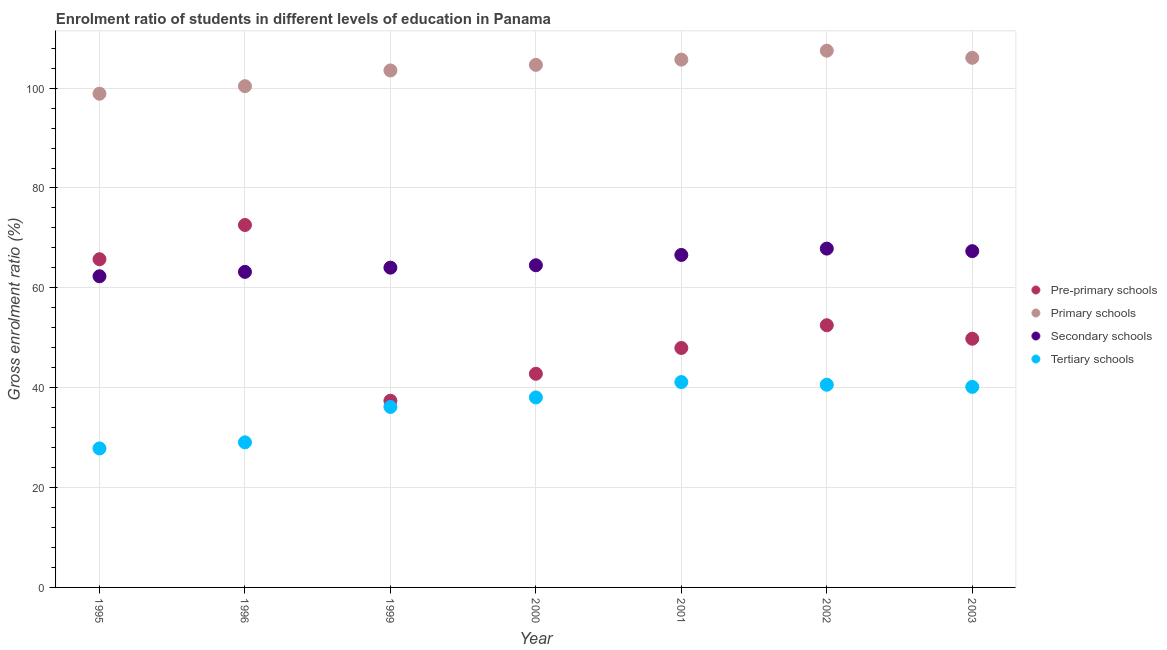How many different coloured dotlines are there?
Your response must be concise. 4. What is the gross enrolment ratio in primary schools in 1996?
Provide a short and direct response. 100.39. Across all years, what is the maximum gross enrolment ratio in tertiary schools?
Keep it short and to the point. 41.13. Across all years, what is the minimum gross enrolment ratio in tertiary schools?
Offer a very short reply. 27.84. In which year was the gross enrolment ratio in primary schools maximum?
Your answer should be compact. 2002. What is the total gross enrolment ratio in secondary schools in the graph?
Your response must be concise. 455.89. What is the difference between the gross enrolment ratio in primary schools in 1996 and that in 2002?
Offer a very short reply. -7.1. What is the difference between the gross enrolment ratio in secondary schools in 2001 and the gross enrolment ratio in tertiary schools in 1999?
Make the answer very short. 30.44. What is the average gross enrolment ratio in tertiary schools per year?
Your answer should be compact. 36.14. In the year 1996, what is the difference between the gross enrolment ratio in tertiary schools and gross enrolment ratio in secondary schools?
Offer a very short reply. -34.14. In how many years, is the gross enrolment ratio in secondary schools greater than 72 %?
Offer a terse response. 0. What is the ratio of the gross enrolment ratio in tertiary schools in 2002 to that in 2003?
Keep it short and to the point. 1.01. Is the difference between the gross enrolment ratio in tertiary schools in 2001 and 2002 greater than the difference between the gross enrolment ratio in pre-primary schools in 2001 and 2002?
Give a very brief answer. Yes. What is the difference between the highest and the second highest gross enrolment ratio in tertiary schools?
Ensure brevity in your answer.  0.53. What is the difference between the highest and the lowest gross enrolment ratio in tertiary schools?
Offer a very short reply. 13.29. Is the sum of the gross enrolment ratio in pre-primary schools in 2001 and 2002 greater than the maximum gross enrolment ratio in tertiary schools across all years?
Make the answer very short. Yes. Does the gross enrolment ratio in tertiary schools monotonically increase over the years?
Offer a terse response. No. Is the gross enrolment ratio in secondary schools strictly greater than the gross enrolment ratio in pre-primary schools over the years?
Provide a succinct answer. No. Is the gross enrolment ratio in secondary schools strictly less than the gross enrolment ratio in pre-primary schools over the years?
Make the answer very short. No. How many dotlines are there?
Offer a terse response. 4. How many years are there in the graph?
Ensure brevity in your answer.  7. What is the difference between two consecutive major ticks on the Y-axis?
Give a very brief answer. 20. Are the values on the major ticks of Y-axis written in scientific E-notation?
Ensure brevity in your answer.  No. Does the graph contain any zero values?
Provide a succinct answer. No. What is the title of the graph?
Your answer should be compact. Enrolment ratio of students in different levels of education in Panama. Does "Plant species" appear as one of the legend labels in the graph?
Your answer should be compact. No. What is the label or title of the X-axis?
Ensure brevity in your answer.  Year. What is the label or title of the Y-axis?
Your answer should be compact. Gross enrolment ratio (%). What is the Gross enrolment ratio (%) of Pre-primary schools in 1995?
Provide a succinct answer. 65.73. What is the Gross enrolment ratio (%) of Primary schools in 1995?
Offer a very short reply. 98.88. What is the Gross enrolment ratio (%) in Secondary schools in 1995?
Keep it short and to the point. 62.32. What is the Gross enrolment ratio (%) in Tertiary schools in 1995?
Provide a short and direct response. 27.84. What is the Gross enrolment ratio (%) in Pre-primary schools in 1996?
Offer a terse response. 72.59. What is the Gross enrolment ratio (%) of Primary schools in 1996?
Your response must be concise. 100.39. What is the Gross enrolment ratio (%) in Secondary schools in 1996?
Your response must be concise. 63.2. What is the Gross enrolment ratio (%) in Tertiary schools in 1996?
Provide a succinct answer. 29.06. What is the Gross enrolment ratio (%) of Pre-primary schools in 1999?
Offer a very short reply. 37.39. What is the Gross enrolment ratio (%) in Primary schools in 1999?
Provide a succinct answer. 103.54. What is the Gross enrolment ratio (%) of Secondary schools in 1999?
Your answer should be compact. 64.04. What is the Gross enrolment ratio (%) in Tertiary schools in 1999?
Offer a very short reply. 36.15. What is the Gross enrolment ratio (%) in Pre-primary schools in 2000?
Offer a very short reply. 42.79. What is the Gross enrolment ratio (%) of Primary schools in 2000?
Your answer should be very brief. 104.66. What is the Gross enrolment ratio (%) in Secondary schools in 2000?
Your response must be concise. 64.52. What is the Gross enrolment ratio (%) in Tertiary schools in 2000?
Your response must be concise. 38.05. What is the Gross enrolment ratio (%) in Pre-primary schools in 2001?
Your answer should be very brief. 47.96. What is the Gross enrolment ratio (%) in Primary schools in 2001?
Your answer should be very brief. 105.71. What is the Gross enrolment ratio (%) of Secondary schools in 2001?
Offer a terse response. 66.59. What is the Gross enrolment ratio (%) in Tertiary schools in 2001?
Your response must be concise. 41.13. What is the Gross enrolment ratio (%) of Pre-primary schools in 2002?
Give a very brief answer. 52.51. What is the Gross enrolment ratio (%) of Primary schools in 2002?
Make the answer very short. 107.49. What is the Gross enrolment ratio (%) in Secondary schools in 2002?
Offer a terse response. 67.86. What is the Gross enrolment ratio (%) of Tertiary schools in 2002?
Your answer should be compact. 40.6. What is the Gross enrolment ratio (%) in Pre-primary schools in 2003?
Give a very brief answer. 49.81. What is the Gross enrolment ratio (%) in Primary schools in 2003?
Your response must be concise. 106.07. What is the Gross enrolment ratio (%) of Secondary schools in 2003?
Your answer should be compact. 67.35. What is the Gross enrolment ratio (%) in Tertiary schools in 2003?
Give a very brief answer. 40.17. Across all years, what is the maximum Gross enrolment ratio (%) of Pre-primary schools?
Your answer should be very brief. 72.59. Across all years, what is the maximum Gross enrolment ratio (%) of Primary schools?
Ensure brevity in your answer.  107.49. Across all years, what is the maximum Gross enrolment ratio (%) in Secondary schools?
Make the answer very short. 67.86. Across all years, what is the maximum Gross enrolment ratio (%) in Tertiary schools?
Your response must be concise. 41.13. Across all years, what is the minimum Gross enrolment ratio (%) of Pre-primary schools?
Offer a terse response. 37.39. Across all years, what is the minimum Gross enrolment ratio (%) of Primary schools?
Give a very brief answer. 98.88. Across all years, what is the minimum Gross enrolment ratio (%) in Secondary schools?
Keep it short and to the point. 62.32. Across all years, what is the minimum Gross enrolment ratio (%) of Tertiary schools?
Provide a succinct answer. 27.84. What is the total Gross enrolment ratio (%) in Pre-primary schools in the graph?
Make the answer very short. 368.78. What is the total Gross enrolment ratio (%) in Primary schools in the graph?
Offer a terse response. 726.75. What is the total Gross enrolment ratio (%) of Secondary schools in the graph?
Offer a terse response. 455.89. What is the total Gross enrolment ratio (%) of Tertiary schools in the graph?
Ensure brevity in your answer.  252.99. What is the difference between the Gross enrolment ratio (%) of Pre-primary schools in 1995 and that in 1996?
Give a very brief answer. -6.86. What is the difference between the Gross enrolment ratio (%) of Primary schools in 1995 and that in 1996?
Your answer should be compact. -1.51. What is the difference between the Gross enrolment ratio (%) of Secondary schools in 1995 and that in 1996?
Provide a short and direct response. -0.88. What is the difference between the Gross enrolment ratio (%) of Tertiary schools in 1995 and that in 1996?
Make the answer very short. -1.22. What is the difference between the Gross enrolment ratio (%) in Pre-primary schools in 1995 and that in 1999?
Offer a terse response. 28.34. What is the difference between the Gross enrolment ratio (%) of Primary schools in 1995 and that in 1999?
Your answer should be compact. -4.66. What is the difference between the Gross enrolment ratio (%) of Secondary schools in 1995 and that in 1999?
Provide a succinct answer. -1.72. What is the difference between the Gross enrolment ratio (%) in Tertiary schools in 1995 and that in 1999?
Your answer should be compact. -8.32. What is the difference between the Gross enrolment ratio (%) in Pre-primary schools in 1995 and that in 2000?
Provide a short and direct response. 22.94. What is the difference between the Gross enrolment ratio (%) of Primary schools in 1995 and that in 2000?
Provide a short and direct response. -5.78. What is the difference between the Gross enrolment ratio (%) in Secondary schools in 1995 and that in 2000?
Keep it short and to the point. -2.2. What is the difference between the Gross enrolment ratio (%) of Tertiary schools in 1995 and that in 2000?
Provide a succinct answer. -10.21. What is the difference between the Gross enrolment ratio (%) of Pre-primary schools in 1995 and that in 2001?
Provide a succinct answer. 17.77. What is the difference between the Gross enrolment ratio (%) in Primary schools in 1995 and that in 2001?
Your answer should be compact. -6.83. What is the difference between the Gross enrolment ratio (%) of Secondary schools in 1995 and that in 2001?
Give a very brief answer. -4.27. What is the difference between the Gross enrolment ratio (%) in Tertiary schools in 1995 and that in 2001?
Offer a very short reply. -13.29. What is the difference between the Gross enrolment ratio (%) of Pre-primary schools in 1995 and that in 2002?
Offer a terse response. 13.22. What is the difference between the Gross enrolment ratio (%) of Primary schools in 1995 and that in 2002?
Give a very brief answer. -8.61. What is the difference between the Gross enrolment ratio (%) of Secondary schools in 1995 and that in 2002?
Provide a succinct answer. -5.54. What is the difference between the Gross enrolment ratio (%) of Tertiary schools in 1995 and that in 2002?
Make the answer very short. -12.76. What is the difference between the Gross enrolment ratio (%) of Pre-primary schools in 1995 and that in 2003?
Keep it short and to the point. 15.92. What is the difference between the Gross enrolment ratio (%) in Primary schools in 1995 and that in 2003?
Your answer should be very brief. -7.19. What is the difference between the Gross enrolment ratio (%) of Secondary schools in 1995 and that in 2003?
Offer a very short reply. -5.03. What is the difference between the Gross enrolment ratio (%) in Tertiary schools in 1995 and that in 2003?
Offer a terse response. -12.33. What is the difference between the Gross enrolment ratio (%) in Pre-primary schools in 1996 and that in 1999?
Make the answer very short. 35.2. What is the difference between the Gross enrolment ratio (%) of Primary schools in 1996 and that in 1999?
Offer a very short reply. -3.15. What is the difference between the Gross enrolment ratio (%) of Secondary schools in 1996 and that in 1999?
Ensure brevity in your answer.  -0.85. What is the difference between the Gross enrolment ratio (%) in Tertiary schools in 1996 and that in 1999?
Your response must be concise. -7.09. What is the difference between the Gross enrolment ratio (%) in Pre-primary schools in 1996 and that in 2000?
Provide a short and direct response. 29.8. What is the difference between the Gross enrolment ratio (%) of Primary schools in 1996 and that in 2000?
Give a very brief answer. -4.27. What is the difference between the Gross enrolment ratio (%) of Secondary schools in 1996 and that in 2000?
Your answer should be very brief. -1.33. What is the difference between the Gross enrolment ratio (%) of Tertiary schools in 1996 and that in 2000?
Provide a succinct answer. -8.99. What is the difference between the Gross enrolment ratio (%) of Pre-primary schools in 1996 and that in 2001?
Ensure brevity in your answer.  24.63. What is the difference between the Gross enrolment ratio (%) of Primary schools in 1996 and that in 2001?
Offer a very short reply. -5.32. What is the difference between the Gross enrolment ratio (%) of Secondary schools in 1996 and that in 2001?
Keep it short and to the point. -3.39. What is the difference between the Gross enrolment ratio (%) of Tertiary schools in 1996 and that in 2001?
Provide a short and direct response. -12.07. What is the difference between the Gross enrolment ratio (%) of Pre-primary schools in 1996 and that in 2002?
Provide a succinct answer. 20.08. What is the difference between the Gross enrolment ratio (%) in Primary schools in 1996 and that in 2002?
Your answer should be very brief. -7.1. What is the difference between the Gross enrolment ratio (%) of Secondary schools in 1996 and that in 2002?
Your response must be concise. -4.66. What is the difference between the Gross enrolment ratio (%) in Tertiary schools in 1996 and that in 2002?
Provide a succinct answer. -11.54. What is the difference between the Gross enrolment ratio (%) of Pre-primary schools in 1996 and that in 2003?
Your response must be concise. 22.78. What is the difference between the Gross enrolment ratio (%) in Primary schools in 1996 and that in 2003?
Provide a short and direct response. -5.68. What is the difference between the Gross enrolment ratio (%) of Secondary schools in 1996 and that in 2003?
Your answer should be compact. -4.15. What is the difference between the Gross enrolment ratio (%) in Tertiary schools in 1996 and that in 2003?
Make the answer very short. -11.11. What is the difference between the Gross enrolment ratio (%) of Pre-primary schools in 1999 and that in 2000?
Offer a very short reply. -5.4. What is the difference between the Gross enrolment ratio (%) of Primary schools in 1999 and that in 2000?
Provide a short and direct response. -1.12. What is the difference between the Gross enrolment ratio (%) of Secondary schools in 1999 and that in 2000?
Provide a short and direct response. -0.48. What is the difference between the Gross enrolment ratio (%) in Tertiary schools in 1999 and that in 2000?
Your answer should be compact. -1.9. What is the difference between the Gross enrolment ratio (%) in Pre-primary schools in 1999 and that in 2001?
Your answer should be very brief. -10.57. What is the difference between the Gross enrolment ratio (%) in Primary schools in 1999 and that in 2001?
Provide a short and direct response. -2.17. What is the difference between the Gross enrolment ratio (%) in Secondary schools in 1999 and that in 2001?
Provide a short and direct response. -2.55. What is the difference between the Gross enrolment ratio (%) of Tertiary schools in 1999 and that in 2001?
Offer a terse response. -4.98. What is the difference between the Gross enrolment ratio (%) of Pre-primary schools in 1999 and that in 2002?
Provide a short and direct response. -15.12. What is the difference between the Gross enrolment ratio (%) of Primary schools in 1999 and that in 2002?
Make the answer very short. -3.95. What is the difference between the Gross enrolment ratio (%) in Secondary schools in 1999 and that in 2002?
Provide a succinct answer. -3.82. What is the difference between the Gross enrolment ratio (%) in Tertiary schools in 1999 and that in 2002?
Give a very brief answer. -4.44. What is the difference between the Gross enrolment ratio (%) in Pre-primary schools in 1999 and that in 2003?
Ensure brevity in your answer.  -12.42. What is the difference between the Gross enrolment ratio (%) of Primary schools in 1999 and that in 2003?
Your answer should be very brief. -2.53. What is the difference between the Gross enrolment ratio (%) of Secondary schools in 1999 and that in 2003?
Provide a short and direct response. -3.31. What is the difference between the Gross enrolment ratio (%) of Tertiary schools in 1999 and that in 2003?
Keep it short and to the point. -4.01. What is the difference between the Gross enrolment ratio (%) of Pre-primary schools in 2000 and that in 2001?
Keep it short and to the point. -5.17. What is the difference between the Gross enrolment ratio (%) in Primary schools in 2000 and that in 2001?
Your answer should be very brief. -1.05. What is the difference between the Gross enrolment ratio (%) of Secondary schools in 2000 and that in 2001?
Give a very brief answer. -2.07. What is the difference between the Gross enrolment ratio (%) in Tertiary schools in 2000 and that in 2001?
Give a very brief answer. -3.08. What is the difference between the Gross enrolment ratio (%) of Pre-primary schools in 2000 and that in 2002?
Provide a succinct answer. -9.72. What is the difference between the Gross enrolment ratio (%) of Primary schools in 2000 and that in 2002?
Your answer should be very brief. -2.83. What is the difference between the Gross enrolment ratio (%) in Secondary schools in 2000 and that in 2002?
Provide a short and direct response. -3.34. What is the difference between the Gross enrolment ratio (%) of Tertiary schools in 2000 and that in 2002?
Offer a terse response. -2.55. What is the difference between the Gross enrolment ratio (%) of Pre-primary schools in 2000 and that in 2003?
Your answer should be very brief. -7.02. What is the difference between the Gross enrolment ratio (%) in Primary schools in 2000 and that in 2003?
Make the answer very short. -1.41. What is the difference between the Gross enrolment ratio (%) in Secondary schools in 2000 and that in 2003?
Provide a short and direct response. -2.83. What is the difference between the Gross enrolment ratio (%) in Tertiary schools in 2000 and that in 2003?
Your response must be concise. -2.12. What is the difference between the Gross enrolment ratio (%) in Pre-primary schools in 2001 and that in 2002?
Your answer should be compact. -4.55. What is the difference between the Gross enrolment ratio (%) of Primary schools in 2001 and that in 2002?
Offer a terse response. -1.78. What is the difference between the Gross enrolment ratio (%) in Secondary schools in 2001 and that in 2002?
Give a very brief answer. -1.27. What is the difference between the Gross enrolment ratio (%) in Tertiary schools in 2001 and that in 2002?
Ensure brevity in your answer.  0.53. What is the difference between the Gross enrolment ratio (%) in Pre-primary schools in 2001 and that in 2003?
Make the answer very short. -1.85. What is the difference between the Gross enrolment ratio (%) of Primary schools in 2001 and that in 2003?
Offer a very short reply. -0.36. What is the difference between the Gross enrolment ratio (%) of Secondary schools in 2001 and that in 2003?
Give a very brief answer. -0.76. What is the difference between the Gross enrolment ratio (%) of Tertiary schools in 2001 and that in 2003?
Provide a short and direct response. 0.96. What is the difference between the Gross enrolment ratio (%) of Pre-primary schools in 2002 and that in 2003?
Offer a terse response. 2.7. What is the difference between the Gross enrolment ratio (%) of Primary schools in 2002 and that in 2003?
Ensure brevity in your answer.  1.42. What is the difference between the Gross enrolment ratio (%) of Secondary schools in 2002 and that in 2003?
Make the answer very short. 0.51. What is the difference between the Gross enrolment ratio (%) of Tertiary schools in 2002 and that in 2003?
Keep it short and to the point. 0.43. What is the difference between the Gross enrolment ratio (%) in Pre-primary schools in 1995 and the Gross enrolment ratio (%) in Primary schools in 1996?
Make the answer very short. -34.66. What is the difference between the Gross enrolment ratio (%) in Pre-primary schools in 1995 and the Gross enrolment ratio (%) in Secondary schools in 1996?
Offer a terse response. 2.54. What is the difference between the Gross enrolment ratio (%) of Pre-primary schools in 1995 and the Gross enrolment ratio (%) of Tertiary schools in 1996?
Your response must be concise. 36.67. What is the difference between the Gross enrolment ratio (%) of Primary schools in 1995 and the Gross enrolment ratio (%) of Secondary schools in 1996?
Make the answer very short. 35.68. What is the difference between the Gross enrolment ratio (%) of Primary schools in 1995 and the Gross enrolment ratio (%) of Tertiary schools in 1996?
Offer a very short reply. 69.82. What is the difference between the Gross enrolment ratio (%) in Secondary schools in 1995 and the Gross enrolment ratio (%) in Tertiary schools in 1996?
Ensure brevity in your answer.  33.26. What is the difference between the Gross enrolment ratio (%) of Pre-primary schools in 1995 and the Gross enrolment ratio (%) of Primary schools in 1999?
Your response must be concise. -37.81. What is the difference between the Gross enrolment ratio (%) in Pre-primary schools in 1995 and the Gross enrolment ratio (%) in Secondary schools in 1999?
Offer a very short reply. 1.69. What is the difference between the Gross enrolment ratio (%) in Pre-primary schools in 1995 and the Gross enrolment ratio (%) in Tertiary schools in 1999?
Provide a short and direct response. 29.58. What is the difference between the Gross enrolment ratio (%) of Primary schools in 1995 and the Gross enrolment ratio (%) of Secondary schools in 1999?
Your response must be concise. 34.84. What is the difference between the Gross enrolment ratio (%) of Primary schools in 1995 and the Gross enrolment ratio (%) of Tertiary schools in 1999?
Your answer should be compact. 62.73. What is the difference between the Gross enrolment ratio (%) in Secondary schools in 1995 and the Gross enrolment ratio (%) in Tertiary schools in 1999?
Make the answer very short. 26.17. What is the difference between the Gross enrolment ratio (%) in Pre-primary schools in 1995 and the Gross enrolment ratio (%) in Primary schools in 2000?
Give a very brief answer. -38.93. What is the difference between the Gross enrolment ratio (%) of Pre-primary schools in 1995 and the Gross enrolment ratio (%) of Secondary schools in 2000?
Your response must be concise. 1.21. What is the difference between the Gross enrolment ratio (%) in Pre-primary schools in 1995 and the Gross enrolment ratio (%) in Tertiary schools in 2000?
Ensure brevity in your answer.  27.68. What is the difference between the Gross enrolment ratio (%) in Primary schools in 1995 and the Gross enrolment ratio (%) in Secondary schools in 2000?
Make the answer very short. 34.36. What is the difference between the Gross enrolment ratio (%) of Primary schools in 1995 and the Gross enrolment ratio (%) of Tertiary schools in 2000?
Ensure brevity in your answer.  60.83. What is the difference between the Gross enrolment ratio (%) in Secondary schools in 1995 and the Gross enrolment ratio (%) in Tertiary schools in 2000?
Your response must be concise. 24.27. What is the difference between the Gross enrolment ratio (%) of Pre-primary schools in 1995 and the Gross enrolment ratio (%) of Primary schools in 2001?
Make the answer very short. -39.98. What is the difference between the Gross enrolment ratio (%) of Pre-primary schools in 1995 and the Gross enrolment ratio (%) of Secondary schools in 2001?
Offer a terse response. -0.86. What is the difference between the Gross enrolment ratio (%) in Pre-primary schools in 1995 and the Gross enrolment ratio (%) in Tertiary schools in 2001?
Give a very brief answer. 24.6. What is the difference between the Gross enrolment ratio (%) in Primary schools in 1995 and the Gross enrolment ratio (%) in Secondary schools in 2001?
Your answer should be very brief. 32.29. What is the difference between the Gross enrolment ratio (%) of Primary schools in 1995 and the Gross enrolment ratio (%) of Tertiary schools in 2001?
Provide a succinct answer. 57.75. What is the difference between the Gross enrolment ratio (%) of Secondary schools in 1995 and the Gross enrolment ratio (%) of Tertiary schools in 2001?
Make the answer very short. 21.19. What is the difference between the Gross enrolment ratio (%) of Pre-primary schools in 1995 and the Gross enrolment ratio (%) of Primary schools in 2002?
Your answer should be very brief. -41.76. What is the difference between the Gross enrolment ratio (%) of Pre-primary schools in 1995 and the Gross enrolment ratio (%) of Secondary schools in 2002?
Offer a very short reply. -2.13. What is the difference between the Gross enrolment ratio (%) in Pre-primary schools in 1995 and the Gross enrolment ratio (%) in Tertiary schools in 2002?
Provide a short and direct response. 25.14. What is the difference between the Gross enrolment ratio (%) in Primary schools in 1995 and the Gross enrolment ratio (%) in Secondary schools in 2002?
Offer a very short reply. 31.02. What is the difference between the Gross enrolment ratio (%) of Primary schools in 1995 and the Gross enrolment ratio (%) of Tertiary schools in 2002?
Keep it short and to the point. 58.28. What is the difference between the Gross enrolment ratio (%) of Secondary schools in 1995 and the Gross enrolment ratio (%) of Tertiary schools in 2002?
Ensure brevity in your answer.  21.73. What is the difference between the Gross enrolment ratio (%) in Pre-primary schools in 1995 and the Gross enrolment ratio (%) in Primary schools in 2003?
Offer a terse response. -40.34. What is the difference between the Gross enrolment ratio (%) in Pre-primary schools in 1995 and the Gross enrolment ratio (%) in Secondary schools in 2003?
Keep it short and to the point. -1.62. What is the difference between the Gross enrolment ratio (%) of Pre-primary schools in 1995 and the Gross enrolment ratio (%) of Tertiary schools in 2003?
Your answer should be compact. 25.57. What is the difference between the Gross enrolment ratio (%) in Primary schools in 1995 and the Gross enrolment ratio (%) in Secondary schools in 2003?
Your answer should be compact. 31.53. What is the difference between the Gross enrolment ratio (%) of Primary schools in 1995 and the Gross enrolment ratio (%) of Tertiary schools in 2003?
Keep it short and to the point. 58.71. What is the difference between the Gross enrolment ratio (%) in Secondary schools in 1995 and the Gross enrolment ratio (%) in Tertiary schools in 2003?
Provide a short and direct response. 22.16. What is the difference between the Gross enrolment ratio (%) of Pre-primary schools in 1996 and the Gross enrolment ratio (%) of Primary schools in 1999?
Provide a succinct answer. -30.95. What is the difference between the Gross enrolment ratio (%) of Pre-primary schools in 1996 and the Gross enrolment ratio (%) of Secondary schools in 1999?
Your response must be concise. 8.54. What is the difference between the Gross enrolment ratio (%) in Pre-primary schools in 1996 and the Gross enrolment ratio (%) in Tertiary schools in 1999?
Keep it short and to the point. 36.43. What is the difference between the Gross enrolment ratio (%) in Primary schools in 1996 and the Gross enrolment ratio (%) in Secondary schools in 1999?
Make the answer very short. 36.35. What is the difference between the Gross enrolment ratio (%) in Primary schools in 1996 and the Gross enrolment ratio (%) in Tertiary schools in 1999?
Offer a very short reply. 64.24. What is the difference between the Gross enrolment ratio (%) of Secondary schools in 1996 and the Gross enrolment ratio (%) of Tertiary schools in 1999?
Ensure brevity in your answer.  27.04. What is the difference between the Gross enrolment ratio (%) of Pre-primary schools in 1996 and the Gross enrolment ratio (%) of Primary schools in 2000?
Your response must be concise. -32.07. What is the difference between the Gross enrolment ratio (%) of Pre-primary schools in 1996 and the Gross enrolment ratio (%) of Secondary schools in 2000?
Offer a very short reply. 8.07. What is the difference between the Gross enrolment ratio (%) in Pre-primary schools in 1996 and the Gross enrolment ratio (%) in Tertiary schools in 2000?
Your answer should be very brief. 34.54. What is the difference between the Gross enrolment ratio (%) in Primary schools in 1996 and the Gross enrolment ratio (%) in Secondary schools in 2000?
Your response must be concise. 35.87. What is the difference between the Gross enrolment ratio (%) in Primary schools in 1996 and the Gross enrolment ratio (%) in Tertiary schools in 2000?
Make the answer very short. 62.34. What is the difference between the Gross enrolment ratio (%) in Secondary schools in 1996 and the Gross enrolment ratio (%) in Tertiary schools in 2000?
Provide a succinct answer. 25.15. What is the difference between the Gross enrolment ratio (%) of Pre-primary schools in 1996 and the Gross enrolment ratio (%) of Primary schools in 2001?
Offer a terse response. -33.12. What is the difference between the Gross enrolment ratio (%) in Pre-primary schools in 1996 and the Gross enrolment ratio (%) in Secondary schools in 2001?
Provide a short and direct response. 6. What is the difference between the Gross enrolment ratio (%) of Pre-primary schools in 1996 and the Gross enrolment ratio (%) of Tertiary schools in 2001?
Your answer should be very brief. 31.46. What is the difference between the Gross enrolment ratio (%) of Primary schools in 1996 and the Gross enrolment ratio (%) of Secondary schools in 2001?
Make the answer very short. 33.8. What is the difference between the Gross enrolment ratio (%) of Primary schools in 1996 and the Gross enrolment ratio (%) of Tertiary schools in 2001?
Offer a very short reply. 59.26. What is the difference between the Gross enrolment ratio (%) in Secondary schools in 1996 and the Gross enrolment ratio (%) in Tertiary schools in 2001?
Your response must be concise. 22.07. What is the difference between the Gross enrolment ratio (%) of Pre-primary schools in 1996 and the Gross enrolment ratio (%) of Primary schools in 2002?
Your answer should be compact. -34.91. What is the difference between the Gross enrolment ratio (%) in Pre-primary schools in 1996 and the Gross enrolment ratio (%) in Secondary schools in 2002?
Your response must be concise. 4.73. What is the difference between the Gross enrolment ratio (%) of Pre-primary schools in 1996 and the Gross enrolment ratio (%) of Tertiary schools in 2002?
Ensure brevity in your answer.  31.99. What is the difference between the Gross enrolment ratio (%) of Primary schools in 1996 and the Gross enrolment ratio (%) of Secondary schools in 2002?
Provide a succinct answer. 32.53. What is the difference between the Gross enrolment ratio (%) in Primary schools in 1996 and the Gross enrolment ratio (%) in Tertiary schools in 2002?
Keep it short and to the point. 59.79. What is the difference between the Gross enrolment ratio (%) of Secondary schools in 1996 and the Gross enrolment ratio (%) of Tertiary schools in 2002?
Ensure brevity in your answer.  22.6. What is the difference between the Gross enrolment ratio (%) of Pre-primary schools in 1996 and the Gross enrolment ratio (%) of Primary schools in 2003?
Give a very brief answer. -33.49. What is the difference between the Gross enrolment ratio (%) of Pre-primary schools in 1996 and the Gross enrolment ratio (%) of Secondary schools in 2003?
Your answer should be compact. 5.24. What is the difference between the Gross enrolment ratio (%) in Pre-primary schools in 1996 and the Gross enrolment ratio (%) in Tertiary schools in 2003?
Your answer should be very brief. 32.42. What is the difference between the Gross enrolment ratio (%) in Primary schools in 1996 and the Gross enrolment ratio (%) in Secondary schools in 2003?
Provide a short and direct response. 33.04. What is the difference between the Gross enrolment ratio (%) in Primary schools in 1996 and the Gross enrolment ratio (%) in Tertiary schools in 2003?
Ensure brevity in your answer.  60.22. What is the difference between the Gross enrolment ratio (%) of Secondary schools in 1996 and the Gross enrolment ratio (%) of Tertiary schools in 2003?
Provide a succinct answer. 23.03. What is the difference between the Gross enrolment ratio (%) in Pre-primary schools in 1999 and the Gross enrolment ratio (%) in Primary schools in 2000?
Your answer should be compact. -67.27. What is the difference between the Gross enrolment ratio (%) of Pre-primary schools in 1999 and the Gross enrolment ratio (%) of Secondary schools in 2000?
Provide a succinct answer. -27.13. What is the difference between the Gross enrolment ratio (%) in Pre-primary schools in 1999 and the Gross enrolment ratio (%) in Tertiary schools in 2000?
Offer a terse response. -0.66. What is the difference between the Gross enrolment ratio (%) of Primary schools in 1999 and the Gross enrolment ratio (%) of Secondary schools in 2000?
Your answer should be very brief. 39.02. What is the difference between the Gross enrolment ratio (%) of Primary schools in 1999 and the Gross enrolment ratio (%) of Tertiary schools in 2000?
Provide a short and direct response. 65.49. What is the difference between the Gross enrolment ratio (%) in Secondary schools in 1999 and the Gross enrolment ratio (%) in Tertiary schools in 2000?
Your answer should be compact. 25.99. What is the difference between the Gross enrolment ratio (%) in Pre-primary schools in 1999 and the Gross enrolment ratio (%) in Primary schools in 2001?
Ensure brevity in your answer.  -68.32. What is the difference between the Gross enrolment ratio (%) in Pre-primary schools in 1999 and the Gross enrolment ratio (%) in Secondary schools in 2001?
Offer a terse response. -29.2. What is the difference between the Gross enrolment ratio (%) in Pre-primary schools in 1999 and the Gross enrolment ratio (%) in Tertiary schools in 2001?
Ensure brevity in your answer.  -3.74. What is the difference between the Gross enrolment ratio (%) of Primary schools in 1999 and the Gross enrolment ratio (%) of Secondary schools in 2001?
Give a very brief answer. 36.95. What is the difference between the Gross enrolment ratio (%) in Primary schools in 1999 and the Gross enrolment ratio (%) in Tertiary schools in 2001?
Provide a succinct answer. 62.41. What is the difference between the Gross enrolment ratio (%) of Secondary schools in 1999 and the Gross enrolment ratio (%) of Tertiary schools in 2001?
Offer a very short reply. 22.91. What is the difference between the Gross enrolment ratio (%) of Pre-primary schools in 1999 and the Gross enrolment ratio (%) of Primary schools in 2002?
Make the answer very short. -70.1. What is the difference between the Gross enrolment ratio (%) in Pre-primary schools in 1999 and the Gross enrolment ratio (%) in Secondary schools in 2002?
Your answer should be very brief. -30.47. What is the difference between the Gross enrolment ratio (%) of Pre-primary schools in 1999 and the Gross enrolment ratio (%) of Tertiary schools in 2002?
Offer a very short reply. -3.21. What is the difference between the Gross enrolment ratio (%) of Primary schools in 1999 and the Gross enrolment ratio (%) of Secondary schools in 2002?
Keep it short and to the point. 35.68. What is the difference between the Gross enrolment ratio (%) in Primary schools in 1999 and the Gross enrolment ratio (%) in Tertiary schools in 2002?
Provide a short and direct response. 62.95. What is the difference between the Gross enrolment ratio (%) in Secondary schools in 1999 and the Gross enrolment ratio (%) in Tertiary schools in 2002?
Make the answer very short. 23.45. What is the difference between the Gross enrolment ratio (%) in Pre-primary schools in 1999 and the Gross enrolment ratio (%) in Primary schools in 2003?
Give a very brief answer. -68.68. What is the difference between the Gross enrolment ratio (%) in Pre-primary schools in 1999 and the Gross enrolment ratio (%) in Secondary schools in 2003?
Provide a succinct answer. -29.96. What is the difference between the Gross enrolment ratio (%) of Pre-primary schools in 1999 and the Gross enrolment ratio (%) of Tertiary schools in 2003?
Make the answer very short. -2.78. What is the difference between the Gross enrolment ratio (%) in Primary schools in 1999 and the Gross enrolment ratio (%) in Secondary schools in 2003?
Keep it short and to the point. 36.19. What is the difference between the Gross enrolment ratio (%) in Primary schools in 1999 and the Gross enrolment ratio (%) in Tertiary schools in 2003?
Ensure brevity in your answer.  63.38. What is the difference between the Gross enrolment ratio (%) in Secondary schools in 1999 and the Gross enrolment ratio (%) in Tertiary schools in 2003?
Make the answer very short. 23.88. What is the difference between the Gross enrolment ratio (%) in Pre-primary schools in 2000 and the Gross enrolment ratio (%) in Primary schools in 2001?
Keep it short and to the point. -62.92. What is the difference between the Gross enrolment ratio (%) in Pre-primary schools in 2000 and the Gross enrolment ratio (%) in Secondary schools in 2001?
Provide a short and direct response. -23.8. What is the difference between the Gross enrolment ratio (%) in Pre-primary schools in 2000 and the Gross enrolment ratio (%) in Tertiary schools in 2001?
Offer a very short reply. 1.66. What is the difference between the Gross enrolment ratio (%) of Primary schools in 2000 and the Gross enrolment ratio (%) of Secondary schools in 2001?
Provide a short and direct response. 38.07. What is the difference between the Gross enrolment ratio (%) of Primary schools in 2000 and the Gross enrolment ratio (%) of Tertiary schools in 2001?
Make the answer very short. 63.53. What is the difference between the Gross enrolment ratio (%) in Secondary schools in 2000 and the Gross enrolment ratio (%) in Tertiary schools in 2001?
Your response must be concise. 23.39. What is the difference between the Gross enrolment ratio (%) in Pre-primary schools in 2000 and the Gross enrolment ratio (%) in Primary schools in 2002?
Your answer should be very brief. -64.7. What is the difference between the Gross enrolment ratio (%) of Pre-primary schools in 2000 and the Gross enrolment ratio (%) of Secondary schools in 2002?
Your response must be concise. -25.07. What is the difference between the Gross enrolment ratio (%) of Pre-primary schools in 2000 and the Gross enrolment ratio (%) of Tertiary schools in 2002?
Ensure brevity in your answer.  2.19. What is the difference between the Gross enrolment ratio (%) of Primary schools in 2000 and the Gross enrolment ratio (%) of Secondary schools in 2002?
Your response must be concise. 36.8. What is the difference between the Gross enrolment ratio (%) in Primary schools in 2000 and the Gross enrolment ratio (%) in Tertiary schools in 2002?
Offer a very short reply. 64.06. What is the difference between the Gross enrolment ratio (%) in Secondary schools in 2000 and the Gross enrolment ratio (%) in Tertiary schools in 2002?
Make the answer very short. 23.93. What is the difference between the Gross enrolment ratio (%) of Pre-primary schools in 2000 and the Gross enrolment ratio (%) of Primary schools in 2003?
Give a very brief answer. -63.28. What is the difference between the Gross enrolment ratio (%) in Pre-primary schools in 2000 and the Gross enrolment ratio (%) in Secondary schools in 2003?
Give a very brief answer. -24.56. What is the difference between the Gross enrolment ratio (%) of Pre-primary schools in 2000 and the Gross enrolment ratio (%) of Tertiary schools in 2003?
Offer a terse response. 2.62. What is the difference between the Gross enrolment ratio (%) in Primary schools in 2000 and the Gross enrolment ratio (%) in Secondary schools in 2003?
Your answer should be very brief. 37.31. What is the difference between the Gross enrolment ratio (%) in Primary schools in 2000 and the Gross enrolment ratio (%) in Tertiary schools in 2003?
Offer a very short reply. 64.49. What is the difference between the Gross enrolment ratio (%) in Secondary schools in 2000 and the Gross enrolment ratio (%) in Tertiary schools in 2003?
Ensure brevity in your answer.  24.36. What is the difference between the Gross enrolment ratio (%) in Pre-primary schools in 2001 and the Gross enrolment ratio (%) in Primary schools in 2002?
Your answer should be very brief. -59.54. What is the difference between the Gross enrolment ratio (%) of Pre-primary schools in 2001 and the Gross enrolment ratio (%) of Secondary schools in 2002?
Offer a terse response. -19.9. What is the difference between the Gross enrolment ratio (%) of Pre-primary schools in 2001 and the Gross enrolment ratio (%) of Tertiary schools in 2002?
Your answer should be very brief. 7.36. What is the difference between the Gross enrolment ratio (%) in Primary schools in 2001 and the Gross enrolment ratio (%) in Secondary schools in 2002?
Ensure brevity in your answer.  37.85. What is the difference between the Gross enrolment ratio (%) of Primary schools in 2001 and the Gross enrolment ratio (%) of Tertiary schools in 2002?
Your answer should be very brief. 65.12. What is the difference between the Gross enrolment ratio (%) of Secondary schools in 2001 and the Gross enrolment ratio (%) of Tertiary schools in 2002?
Provide a succinct answer. 25.99. What is the difference between the Gross enrolment ratio (%) in Pre-primary schools in 2001 and the Gross enrolment ratio (%) in Primary schools in 2003?
Ensure brevity in your answer.  -58.12. What is the difference between the Gross enrolment ratio (%) of Pre-primary schools in 2001 and the Gross enrolment ratio (%) of Secondary schools in 2003?
Make the answer very short. -19.39. What is the difference between the Gross enrolment ratio (%) in Pre-primary schools in 2001 and the Gross enrolment ratio (%) in Tertiary schools in 2003?
Offer a very short reply. 7.79. What is the difference between the Gross enrolment ratio (%) of Primary schools in 2001 and the Gross enrolment ratio (%) of Secondary schools in 2003?
Offer a terse response. 38.36. What is the difference between the Gross enrolment ratio (%) of Primary schools in 2001 and the Gross enrolment ratio (%) of Tertiary schools in 2003?
Your answer should be very brief. 65.55. What is the difference between the Gross enrolment ratio (%) of Secondary schools in 2001 and the Gross enrolment ratio (%) of Tertiary schools in 2003?
Offer a very short reply. 26.42. What is the difference between the Gross enrolment ratio (%) in Pre-primary schools in 2002 and the Gross enrolment ratio (%) in Primary schools in 2003?
Your response must be concise. -53.56. What is the difference between the Gross enrolment ratio (%) in Pre-primary schools in 2002 and the Gross enrolment ratio (%) in Secondary schools in 2003?
Your response must be concise. -14.84. What is the difference between the Gross enrolment ratio (%) of Pre-primary schools in 2002 and the Gross enrolment ratio (%) of Tertiary schools in 2003?
Your answer should be compact. 12.35. What is the difference between the Gross enrolment ratio (%) in Primary schools in 2002 and the Gross enrolment ratio (%) in Secondary schools in 2003?
Your response must be concise. 40.14. What is the difference between the Gross enrolment ratio (%) of Primary schools in 2002 and the Gross enrolment ratio (%) of Tertiary schools in 2003?
Give a very brief answer. 67.33. What is the difference between the Gross enrolment ratio (%) of Secondary schools in 2002 and the Gross enrolment ratio (%) of Tertiary schools in 2003?
Ensure brevity in your answer.  27.69. What is the average Gross enrolment ratio (%) in Pre-primary schools per year?
Offer a very short reply. 52.68. What is the average Gross enrolment ratio (%) of Primary schools per year?
Give a very brief answer. 103.82. What is the average Gross enrolment ratio (%) of Secondary schools per year?
Make the answer very short. 65.13. What is the average Gross enrolment ratio (%) of Tertiary schools per year?
Keep it short and to the point. 36.14. In the year 1995, what is the difference between the Gross enrolment ratio (%) of Pre-primary schools and Gross enrolment ratio (%) of Primary schools?
Give a very brief answer. -33.15. In the year 1995, what is the difference between the Gross enrolment ratio (%) of Pre-primary schools and Gross enrolment ratio (%) of Secondary schools?
Make the answer very short. 3.41. In the year 1995, what is the difference between the Gross enrolment ratio (%) in Pre-primary schools and Gross enrolment ratio (%) in Tertiary schools?
Your answer should be very brief. 37.9. In the year 1995, what is the difference between the Gross enrolment ratio (%) of Primary schools and Gross enrolment ratio (%) of Secondary schools?
Your answer should be compact. 36.56. In the year 1995, what is the difference between the Gross enrolment ratio (%) of Primary schools and Gross enrolment ratio (%) of Tertiary schools?
Give a very brief answer. 71.04. In the year 1995, what is the difference between the Gross enrolment ratio (%) of Secondary schools and Gross enrolment ratio (%) of Tertiary schools?
Provide a succinct answer. 34.49. In the year 1996, what is the difference between the Gross enrolment ratio (%) in Pre-primary schools and Gross enrolment ratio (%) in Primary schools?
Make the answer very short. -27.8. In the year 1996, what is the difference between the Gross enrolment ratio (%) of Pre-primary schools and Gross enrolment ratio (%) of Secondary schools?
Provide a short and direct response. 9.39. In the year 1996, what is the difference between the Gross enrolment ratio (%) in Pre-primary schools and Gross enrolment ratio (%) in Tertiary schools?
Ensure brevity in your answer.  43.53. In the year 1996, what is the difference between the Gross enrolment ratio (%) of Primary schools and Gross enrolment ratio (%) of Secondary schools?
Offer a terse response. 37.19. In the year 1996, what is the difference between the Gross enrolment ratio (%) in Primary schools and Gross enrolment ratio (%) in Tertiary schools?
Your response must be concise. 71.33. In the year 1996, what is the difference between the Gross enrolment ratio (%) of Secondary schools and Gross enrolment ratio (%) of Tertiary schools?
Your answer should be very brief. 34.14. In the year 1999, what is the difference between the Gross enrolment ratio (%) of Pre-primary schools and Gross enrolment ratio (%) of Primary schools?
Your response must be concise. -66.15. In the year 1999, what is the difference between the Gross enrolment ratio (%) in Pre-primary schools and Gross enrolment ratio (%) in Secondary schools?
Make the answer very short. -26.65. In the year 1999, what is the difference between the Gross enrolment ratio (%) in Pre-primary schools and Gross enrolment ratio (%) in Tertiary schools?
Give a very brief answer. 1.24. In the year 1999, what is the difference between the Gross enrolment ratio (%) of Primary schools and Gross enrolment ratio (%) of Secondary schools?
Give a very brief answer. 39.5. In the year 1999, what is the difference between the Gross enrolment ratio (%) in Primary schools and Gross enrolment ratio (%) in Tertiary schools?
Give a very brief answer. 67.39. In the year 1999, what is the difference between the Gross enrolment ratio (%) of Secondary schools and Gross enrolment ratio (%) of Tertiary schools?
Offer a very short reply. 27.89. In the year 2000, what is the difference between the Gross enrolment ratio (%) in Pre-primary schools and Gross enrolment ratio (%) in Primary schools?
Your answer should be compact. -61.87. In the year 2000, what is the difference between the Gross enrolment ratio (%) in Pre-primary schools and Gross enrolment ratio (%) in Secondary schools?
Your answer should be very brief. -21.73. In the year 2000, what is the difference between the Gross enrolment ratio (%) of Pre-primary schools and Gross enrolment ratio (%) of Tertiary schools?
Offer a terse response. 4.74. In the year 2000, what is the difference between the Gross enrolment ratio (%) of Primary schools and Gross enrolment ratio (%) of Secondary schools?
Offer a very short reply. 40.14. In the year 2000, what is the difference between the Gross enrolment ratio (%) in Primary schools and Gross enrolment ratio (%) in Tertiary schools?
Give a very brief answer. 66.61. In the year 2000, what is the difference between the Gross enrolment ratio (%) in Secondary schools and Gross enrolment ratio (%) in Tertiary schools?
Your answer should be compact. 26.47. In the year 2001, what is the difference between the Gross enrolment ratio (%) of Pre-primary schools and Gross enrolment ratio (%) of Primary schools?
Provide a succinct answer. -57.75. In the year 2001, what is the difference between the Gross enrolment ratio (%) of Pre-primary schools and Gross enrolment ratio (%) of Secondary schools?
Make the answer very short. -18.63. In the year 2001, what is the difference between the Gross enrolment ratio (%) in Pre-primary schools and Gross enrolment ratio (%) in Tertiary schools?
Give a very brief answer. 6.83. In the year 2001, what is the difference between the Gross enrolment ratio (%) of Primary schools and Gross enrolment ratio (%) of Secondary schools?
Your answer should be compact. 39.12. In the year 2001, what is the difference between the Gross enrolment ratio (%) of Primary schools and Gross enrolment ratio (%) of Tertiary schools?
Offer a very short reply. 64.58. In the year 2001, what is the difference between the Gross enrolment ratio (%) in Secondary schools and Gross enrolment ratio (%) in Tertiary schools?
Offer a terse response. 25.46. In the year 2002, what is the difference between the Gross enrolment ratio (%) in Pre-primary schools and Gross enrolment ratio (%) in Primary schools?
Your answer should be compact. -54.98. In the year 2002, what is the difference between the Gross enrolment ratio (%) of Pre-primary schools and Gross enrolment ratio (%) of Secondary schools?
Your answer should be very brief. -15.35. In the year 2002, what is the difference between the Gross enrolment ratio (%) in Pre-primary schools and Gross enrolment ratio (%) in Tertiary schools?
Make the answer very short. 11.92. In the year 2002, what is the difference between the Gross enrolment ratio (%) in Primary schools and Gross enrolment ratio (%) in Secondary schools?
Ensure brevity in your answer.  39.63. In the year 2002, what is the difference between the Gross enrolment ratio (%) in Primary schools and Gross enrolment ratio (%) in Tertiary schools?
Give a very brief answer. 66.9. In the year 2002, what is the difference between the Gross enrolment ratio (%) of Secondary schools and Gross enrolment ratio (%) of Tertiary schools?
Offer a terse response. 27.26. In the year 2003, what is the difference between the Gross enrolment ratio (%) of Pre-primary schools and Gross enrolment ratio (%) of Primary schools?
Provide a succinct answer. -56.26. In the year 2003, what is the difference between the Gross enrolment ratio (%) of Pre-primary schools and Gross enrolment ratio (%) of Secondary schools?
Make the answer very short. -17.54. In the year 2003, what is the difference between the Gross enrolment ratio (%) in Pre-primary schools and Gross enrolment ratio (%) in Tertiary schools?
Ensure brevity in your answer.  9.64. In the year 2003, what is the difference between the Gross enrolment ratio (%) in Primary schools and Gross enrolment ratio (%) in Secondary schools?
Ensure brevity in your answer.  38.72. In the year 2003, what is the difference between the Gross enrolment ratio (%) of Primary schools and Gross enrolment ratio (%) of Tertiary schools?
Give a very brief answer. 65.91. In the year 2003, what is the difference between the Gross enrolment ratio (%) in Secondary schools and Gross enrolment ratio (%) in Tertiary schools?
Offer a very short reply. 27.18. What is the ratio of the Gross enrolment ratio (%) in Pre-primary schools in 1995 to that in 1996?
Give a very brief answer. 0.91. What is the ratio of the Gross enrolment ratio (%) of Primary schools in 1995 to that in 1996?
Keep it short and to the point. 0.98. What is the ratio of the Gross enrolment ratio (%) of Secondary schools in 1995 to that in 1996?
Your answer should be compact. 0.99. What is the ratio of the Gross enrolment ratio (%) in Tertiary schools in 1995 to that in 1996?
Ensure brevity in your answer.  0.96. What is the ratio of the Gross enrolment ratio (%) in Pre-primary schools in 1995 to that in 1999?
Offer a terse response. 1.76. What is the ratio of the Gross enrolment ratio (%) in Primary schools in 1995 to that in 1999?
Make the answer very short. 0.95. What is the ratio of the Gross enrolment ratio (%) in Secondary schools in 1995 to that in 1999?
Keep it short and to the point. 0.97. What is the ratio of the Gross enrolment ratio (%) of Tertiary schools in 1995 to that in 1999?
Provide a succinct answer. 0.77. What is the ratio of the Gross enrolment ratio (%) in Pre-primary schools in 1995 to that in 2000?
Provide a short and direct response. 1.54. What is the ratio of the Gross enrolment ratio (%) in Primary schools in 1995 to that in 2000?
Offer a terse response. 0.94. What is the ratio of the Gross enrolment ratio (%) in Secondary schools in 1995 to that in 2000?
Your answer should be very brief. 0.97. What is the ratio of the Gross enrolment ratio (%) of Tertiary schools in 1995 to that in 2000?
Offer a terse response. 0.73. What is the ratio of the Gross enrolment ratio (%) of Pre-primary schools in 1995 to that in 2001?
Offer a terse response. 1.37. What is the ratio of the Gross enrolment ratio (%) in Primary schools in 1995 to that in 2001?
Provide a succinct answer. 0.94. What is the ratio of the Gross enrolment ratio (%) of Secondary schools in 1995 to that in 2001?
Your answer should be very brief. 0.94. What is the ratio of the Gross enrolment ratio (%) in Tertiary schools in 1995 to that in 2001?
Give a very brief answer. 0.68. What is the ratio of the Gross enrolment ratio (%) of Pre-primary schools in 1995 to that in 2002?
Offer a very short reply. 1.25. What is the ratio of the Gross enrolment ratio (%) in Primary schools in 1995 to that in 2002?
Your answer should be very brief. 0.92. What is the ratio of the Gross enrolment ratio (%) of Secondary schools in 1995 to that in 2002?
Keep it short and to the point. 0.92. What is the ratio of the Gross enrolment ratio (%) in Tertiary schools in 1995 to that in 2002?
Offer a very short reply. 0.69. What is the ratio of the Gross enrolment ratio (%) of Pre-primary schools in 1995 to that in 2003?
Your answer should be compact. 1.32. What is the ratio of the Gross enrolment ratio (%) in Primary schools in 1995 to that in 2003?
Your answer should be very brief. 0.93. What is the ratio of the Gross enrolment ratio (%) in Secondary schools in 1995 to that in 2003?
Your answer should be very brief. 0.93. What is the ratio of the Gross enrolment ratio (%) of Tertiary schools in 1995 to that in 2003?
Make the answer very short. 0.69. What is the ratio of the Gross enrolment ratio (%) of Pre-primary schools in 1996 to that in 1999?
Provide a succinct answer. 1.94. What is the ratio of the Gross enrolment ratio (%) of Primary schools in 1996 to that in 1999?
Give a very brief answer. 0.97. What is the ratio of the Gross enrolment ratio (%) of Secondary schools in 1996 to that in 1999?
Make the answer very short. 0.99. What is the ratio of the Gross enrolment ratio (%) of Tertiary schools in 1996 to that in 1999?
Your answer should be very brief. 0.8. What is the ratio of the Gross enrolment ratio (%) in Pre-primary schools in 1996 to that in 2000?
Ensure brevity in your answer.  1.7. What is the ratio of the Gross enrolment ratio (%) in Primary schools in 1996 to that in 2000?
Offer a terse response. 0.96. What is the ratio of the Gross enrolment ratio (%) of Secondary schools in 1996 to that in 2000?
Give a very brief answer. 0.98. What is the ratio of the Gross enrolment ratio (%) in Tertiary schools in 1996 to that in 2000?
Keep it short and to the point. 0.76. What is the ratio of the Gross enrolment ratio (%) of Pre-primary schools in 1996 to that in 2001?
Provide a short and direct response. 1.51. What is the ratio of the Gross enrolment ratio (%) of Primary schools in 1996 to that in 2001?
Provide a succinct answer. 0.95. What is the ratio of the Gross enrolment ratio (%) in Secondary schools in 1996 to that in 2001?
Provide a succinct answer. 0.95. What is the ratio of the Gross enrolment ratio (%) in Tertiary schools in 1996 to that in 2001?
Make the answer very short. 0.71. What is the ratio of the Gross enrolment ratio (%) of Pre-primary schools in 1996 to that in 2002?
Offer a very short reply. 1.38. What is the ratio of the Gross enrolment ratio (%) of Primary schools in 1996 to that in 2002?
Offer a very short reply. 0.93. What is the ratio of the Gross enrolment ratio (%) in Secondary schools in 1996 to that in 2002?
Your response must be concise. 0.93. What is the ratio of the Gross enrolment ratio (%) of Tertiary schools in 1996 to that in 2002?
Your answer should be compact. 0.72. What is the ratio of the Gross enrolment ratio (%) of Pre-primary schools in 1996 to that in 2003?
Offer a terse response. 1.46. What is the ratio of the Gross enrolment ratio (%) in Primary schools in 1996 to that in 2003?
Provide a short and direct response. 0.95. What is the ratio of the Gross enrolment ratio (%) in Secondary schools in 1996 to that in 2003?
Give a very brief answer. 0.94. What is the ratio of the Gross enrolment ratio (%) of Tertiary schools in 1996 to that in 2003?
Keep it short and to the point. 0.72. What is the ratio of the Gross enrolment ratio (%) in Pre-primary schools in 1999 to that in 2000?
Make the answer very short. 0.87. What is the ratio of the Gross enrolment ratio (%) of Primary schools in 1999 to that in 2000?
Ensure brevity in your answer.  0.99. What is the ratio of the Gross enrolment ratio (%) of Tertiary schools in 1999 to that in 2000?
Your answer should be compact. 0.95. What is the ratio of the Gross enrolment ratio (%) of Pre-primary schools in 1999 to that in 2001?
Your response must be concise. 0.78. What is the ratio of the Gross enrolment ratio (%) of Primary schools in 1999 to that in 2001?
Your answer should be compact. 0.98. What is the ratio of the Gross enrolment ratio (%) in Secondary schools in 1999 to that in 2001?
Your answer should be very brief. 0.96. What is the ratio of the Gross enrolment ratio (%) in Tertiary schools in 1999 to that in 2001?
Your answer should be very brief. 0.88. What is the ratio of the Gross enrolment ratio (%) in Pre-primary schools in 1999 to that in 2002?
Offer a terse response. 0.71. What is the ratio of the Gross enrolment ratio (%) of Primary schools in 1999 to that in 2002?
Make the answer very short. 0.96. What is the ratio of the Gross enrolment ratio (%) of Secondary schools in 1999 to that in 2002?
Your answer should be compact. 0.94. What is the ratio of the Gross enrolment ratio (%) in Tertiary schools in 1999 to that in 2002?
Your answer should be very brief. 0.89. What is the ratio of the Gross enrolment ratio (%) in Pre-primary schools in 1999 to that in 2003?
Your answer should be compact. 0.75. What is the ratio of the Gross enrolment ratio (%) in Primary schools in 1999 to that in 2003?
Your response must be concise. 0.98. What is the ratio of the Gross enrolment ratio (%) in Secondary schools in 1999 to that in 2003?
Keep it short and to the point. 0.95. What is the ratio of the Gross enrolment ratio (%) of Tertiary schools in 1999 to that in 2003?
Your response must be concise. 0.9. What is the ratio of the Gross enrolment ratio (%) of Pre-primary schools in 2000 to that in 2001?
Keep it short and to the point. 0.89. What is the ratio of the Gross enrolment ratio (%) in Primary schools in 2000 to that in 2001?
Provide a succinct answer. 0.99. What is the ratio of the Gross enrolment ratio (%) in Secondary schools in 2000 to that in 2001?
Provide a succinct answer. 0.97. What is the ratio of the Gross enrolment ratio (%) in Tertiary schools in 2000 to that in 2001?
Ensure brevity in your answer.  0.93. What is the ratio of the Gross enrolment ratio (%) of Pre-primary schools in 2000 to that in 2002?
Provide a short and direct response. 0.81. What is the ratio of the Gross enrolment ratio (%) in Primary schools in 2000 to that in 2002?
Your answer should be very brief. 0.97. What is the ratio of the Gross enrolment ratio (%) of Secondary schools in 2000 to that in 2002?
Your response must be concise. 0.95. What is the ratio of the Gross enrolment ratio (%) of Tertiary schools in 2000 to that in 2002?
Provide a short and direct response. 0.94. What is the ratio of the Gross enrolment ratio (%) in Pre-primary schools in 2000 to that in 2003?
Make the answer very short. 0.86. What is the ratio of the Gross enrolment ratio (%) in Primary schools in 2000 to that in 2003?
Provide a short and direct response. 0.99. What is the ratio of the Gross enrolment ratio (%) of Secondary schools in 2000 to that in 2003?
Your answer should be very brief. 0.96. What is the ratio of the Gross enrolment ratio (%) in Tertiary schools in 2000 to that in 2003?
Your answer should be very brief. 0.95. What is the ratio of the Gross enrolment ratio (%) of Pre-primary schools in 2001 to that in 2002?
Ensure brevity in your answer.  0.91. What is the ratio of the Gross enrolment ratio (%) in Primary schools in 2001 to that in 2002?
Make the answer very short. 0.98. What is the ratio of the Gross enrolment ratio (%) of Secondary schools in 2001 to that in 2002?
Provide a succinct answer. 0.98. What is the ratio of the Gross enrolment ratio (%) in Tertiary schools in 2001 to that in 2002?
Provide a succinct answer. 1.01. What is the ratio of the Gross enrolment ratio (%) in Pre-primary schools in 2001 to that in 2003?
Your answer should be compact. 0.96. What is the ratio of the Gross enrolment ratio (%) in Secondary schools in 2001 to that in 2003?
Offer a terse response. 0.99. What is the ratio of the Gross enrolment ratio (%) of Tertiary schools in 2001 to that in 2003?
Offer a very short reply. 1.02. What is the ratio of the Gross enrolment ratio (%) in Pre-primary schools in 2002 to that in 2003?
Your response must be concise. 1.05. What is the ratio of the Gross enrolment ratio (%) of Primary schools in 2002 to that in 2003?
Keep it short and to the point. 1.01. What is the ratio of the Gross enrolment ratio (%) of Secondary schools in 2002 to that in 2003?
Your response must be concise. 1.01. What is the ratio of the Gross enrolment ratio (%) in Tertiary schools in 2002 to that in 2003?
Offer a terse response. 1.01. What is the difference between the highest and the second highest Gross enrolment ratio (%) in Pre-primary schools?
Your answer should be very brief. 6.86. What is the difference between the highest and the second highest Gross enrolment ratio (%) of Primary schools?
Keep it short and to the point. 1.42. What is the difference between the highest and the second highest Gross enrolment ratio (%) in Secondary schools?
Offer a terse response. 0.51. What is the difference between the highest and the second highest Gross enrolment ratio (%) of Tertiary schools?
Give a very brief answer. 0.53. What is the difference between the highest and the lowest Gross enrolment ratio (%) of Pre-primary schools?
Your answer should be very brief. 35.2. What is the difference between the highest and the lowest Gross enrolment ratio (%) in Primary schools?
Make the answer very short. 8.61. What is the difference between the highest and the lowest Gross enrolment ratio (%) in Secondary schools?
Give a very brief answer. 5.54. What is the difference between the highest and the lowest Gross enrolment ratio (%) of Tertiary schools?
Make the answer very short. 13.29. 